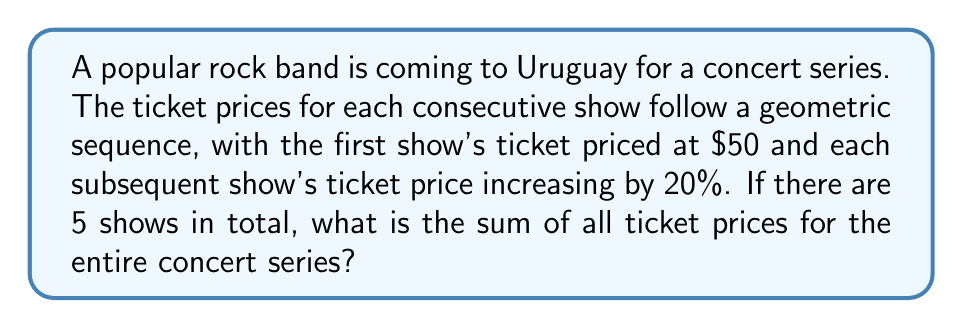Could you help me with this problem? Let's approach this step-by-step:

1) First, we need to identify the components of our geometric sequence:
   - $a_1 = 50$ (first term)
   - $r = 1.20$ (common ratio, as price increases by 20% each time)
   - $n = 5$ (number of terms)

2) The formula for the sum of a geometric sequence is:

   $$S_n = \frac{a_1(1-r^n)}{1-r}$$

   Where $S_n$ is the sum, $a_1$ is the first term, $r$ is the common ratio, and $n$ is the number of terms.

3) Let's substitute our values:

   $$S_5 = \frac{50(1-1.20^5)}{1-1.20}$$

4) Calculate $1.20^5$:
   
   $$1.20^5 = 2.4883$$

5) Now our equation looks like:

   $$S_5 = \frac{50(1-2.4883)}{1-1.20} = \frac{50(-1.4883)}{-0.20}$$

6) Simplify:

   $$S_5 = \frac{74.415}{0.20} = 372.075$$

7) Round to the nearest cent:

   $$S_5 \approx 372.08$$
Answer: $372.08 